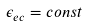<formula> <loc_0><loc_0><loc_500><loc_500>\epsilon _ { e c } = c o n s t</formula> 